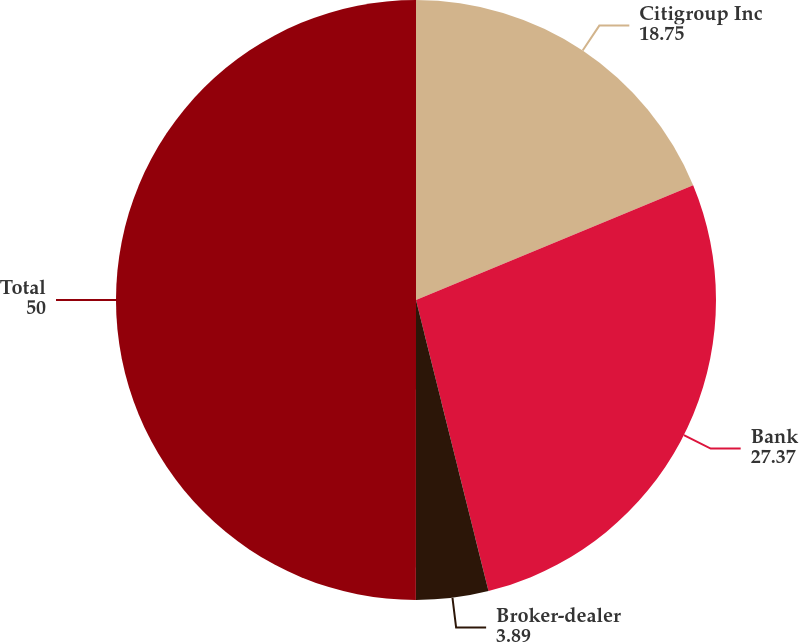Convert chart to OTSL. <chart><loc_0><loc_0><loc_500><loc_500><pie_chart><fcel>Citigroup Inc<fcel>Bank<fcel>Broker-dealer<fcel>Total<nl><fcel>18.75%<fcel>27.37%<fcel>3.89%<fcel>50.0%<nl></chart> 